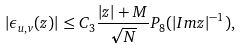Convert formula to latex. <formula><loc_0><loc_0><loc_500><loc_500>| \epsilon _ { u , v } ( z ) | \leq C _ { 3 } \frac { | z | + M } { \sqrt { N } } P _ { 8 } ( | I m z | ^ { - 1 } ) ,</formula> 